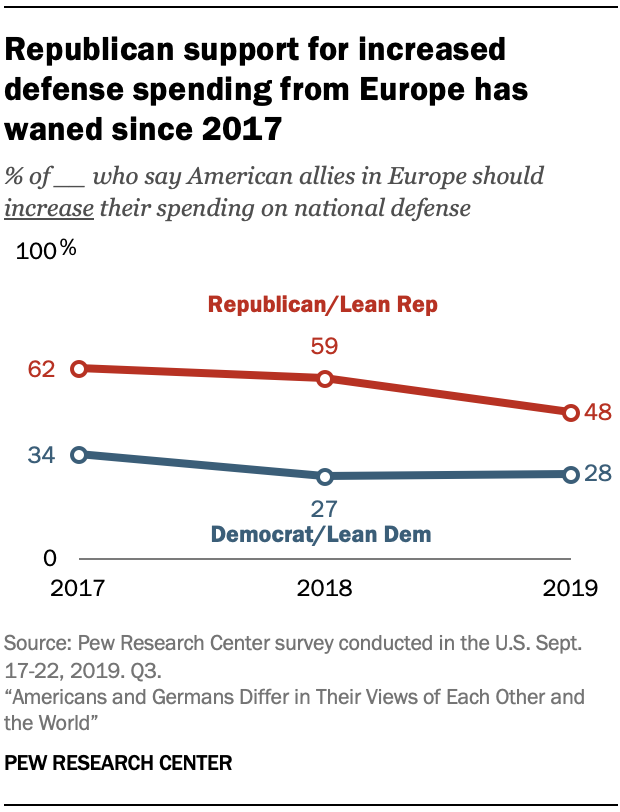Indicate a few pertinent items in this graphic. In 2018, 59% of Republican and leaning Republican voters believed that American allies in Europe should increase their spending on national defense. The median value of the red graph is 59. 